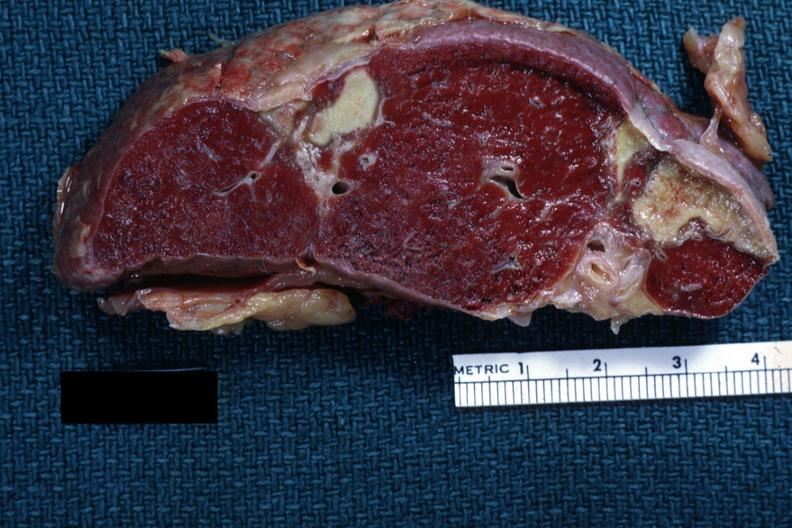what is present?
Answer the question using a single word or phrase. Hematologic 